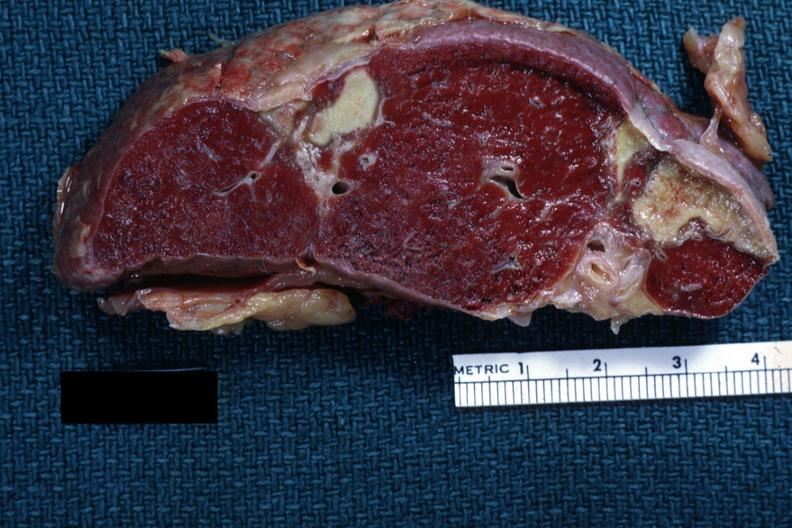what is present?
Answer the question using a single word or phrase. Hematologic 